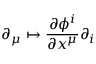<formula> <loc_0><loc_0><loc_500><loc_500>\partial _ { \mu } \mapsto { \frac { \partial \phi ^ { i } } { \partial x ^ { \mu } } } \partial _ { i }</formula> 